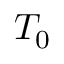<formula> <loc_0><loc_0><loc_500><loc_500>T _ { 0 }</formula> 